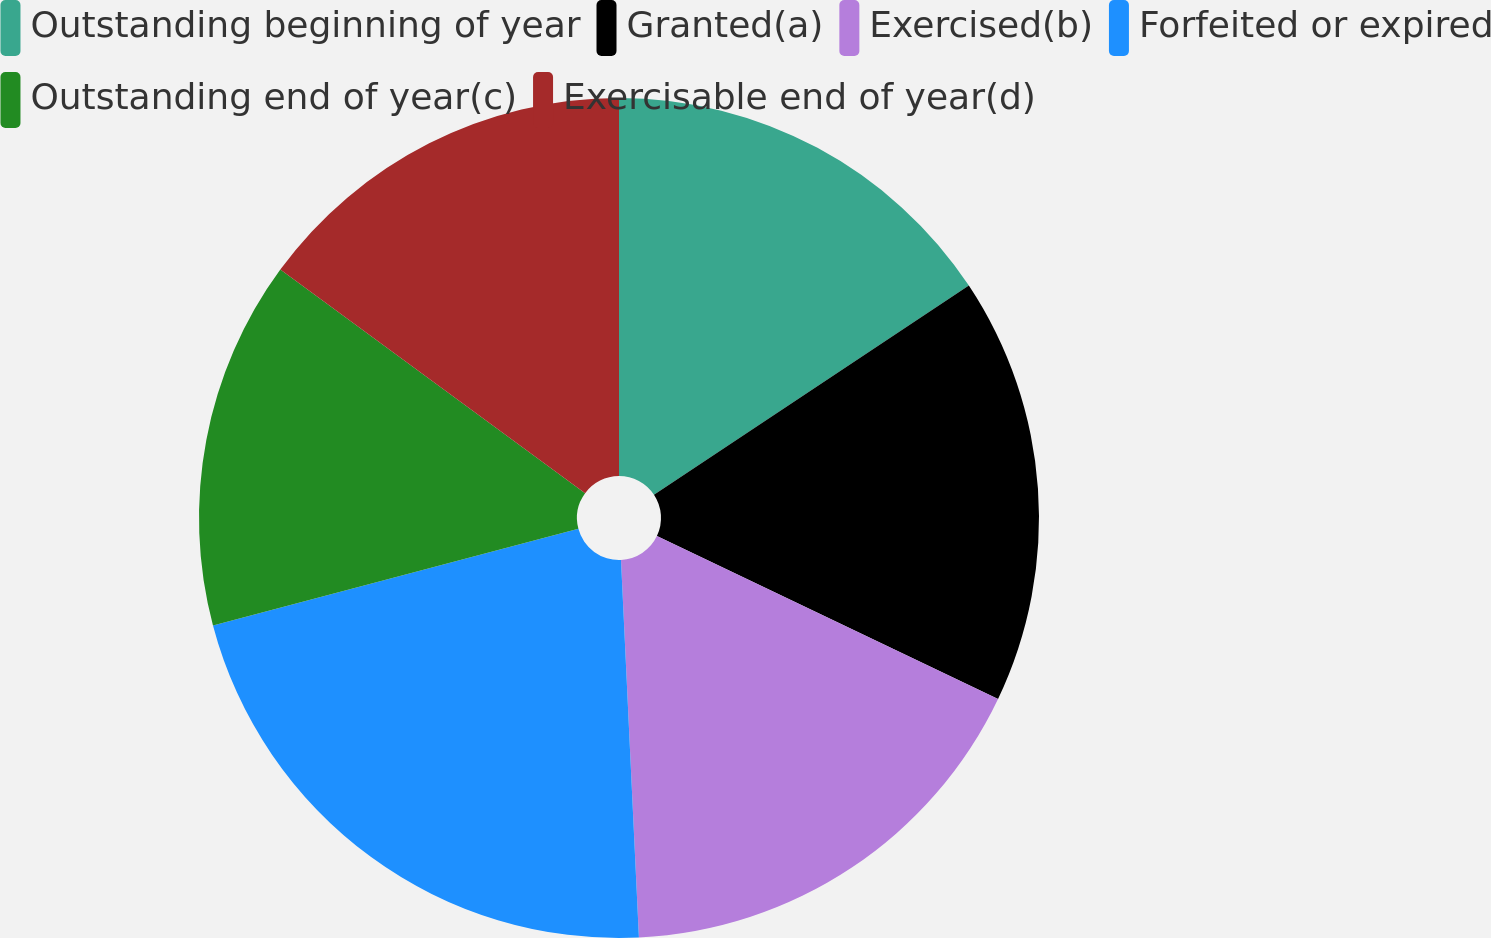Convert chart. <chart><loc_0><loc_0><loc_500><loc_500><pie_chart><fcel>Outstanding beginning of year<fcel>Granted(a)<fcel>Exercised(b)<fcel>Forfeited or expired<fcel>Outstanding end of year(c)<fcel>Exercisable end of year(d)<nl><fcel>15.67%<fcel>16.42%<fcel>17.16%<fcel>21.64%<fcel>14.19%<fcel>14.93%<nl></chart> 